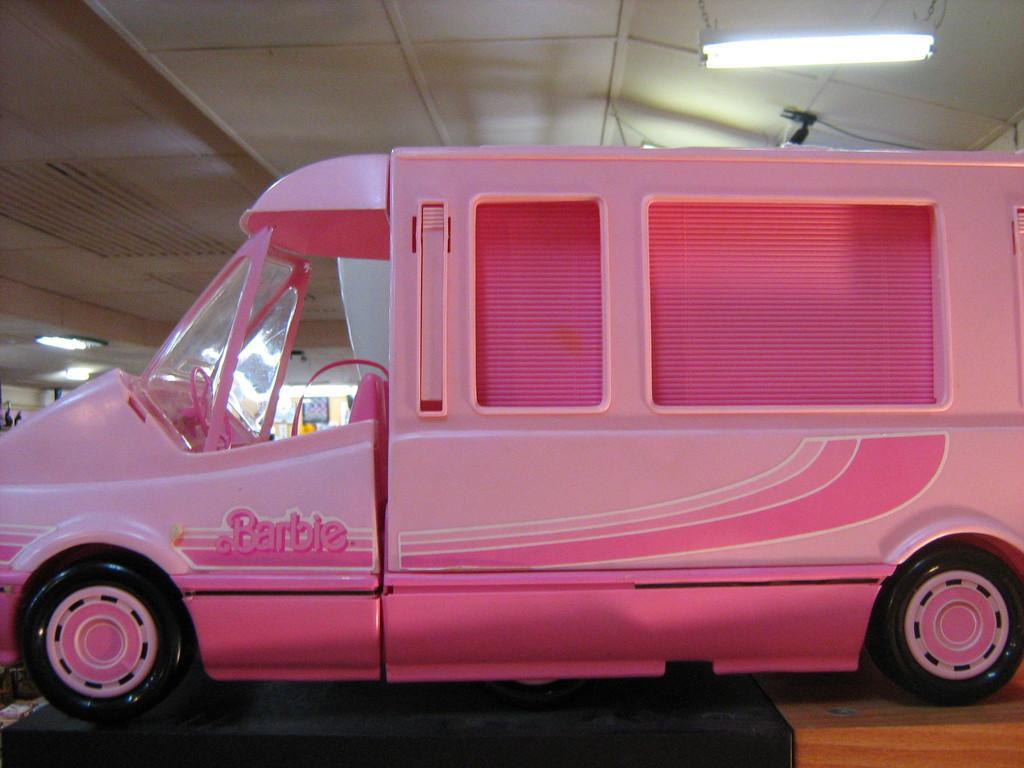In one or two sentences, can you explain what this image depicts? In this picture we can see a vehicle on the ground and in the background we can see a roof, lights and some objects. 